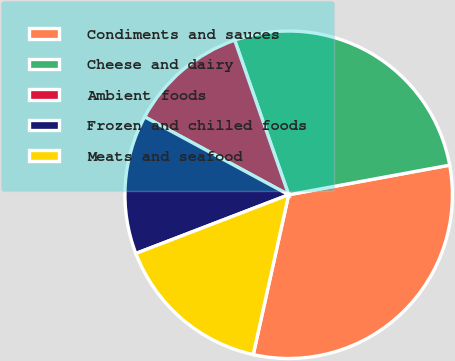Convert chart to OTSL. <chart><loc_0><loc_0><loc_500><loc_500><pie_chart><fcel>Condiments and sauces<fcel>Cheese and dairy<fcel>Ambient foods<fcel>Frozen and chilled foods<fcel>Meats and seafood<nl><fcel>31.37%<fcel>27.45%<fcel>11.76%<fcel>13.73%<fcel>15.69%<nl></chart> 